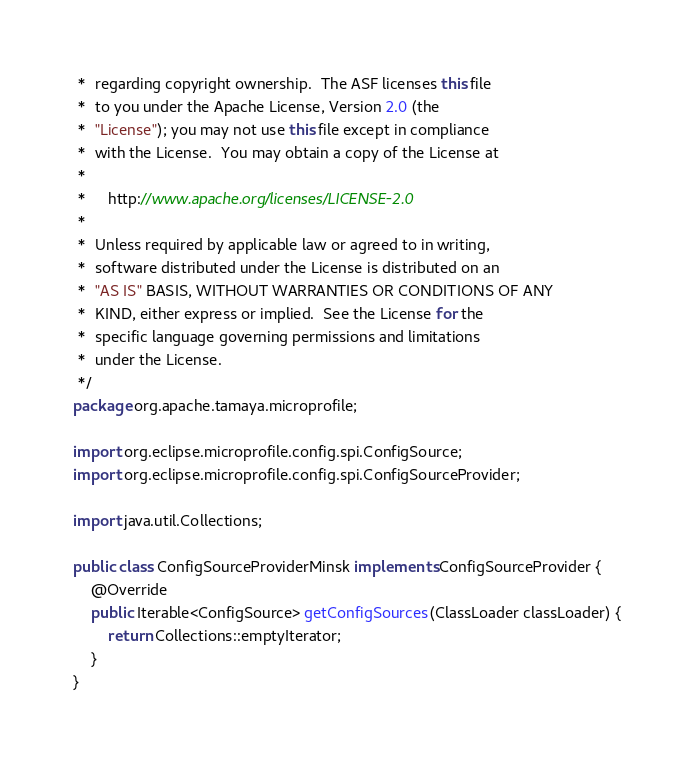<code> <loc_0><loc_0><loc_500><loc_500><_Java_> *  regarding copyright ownership.  The ASF licenses this file
 *  to you under the Apache License, Version 2.0 (the
 *  "License"); you may not use this file except in compliance
 *  with the License.  You may obtain a copy of the License at
 *
 *     http://www.apache.org/licenses/LICENSE-2.0
 *
 *  Unless required by applicable law or agreed to in writing,
 *  software distributed under the License is distributed on an
 *  "AS IS" BASIS, WITHOUT WARRANTIES OR CONDITIONS OF ANY
 *  KIND, either express or implied.  See the License for the
 *  specific language governing permissions and limitations
 *  under the License.
 */
package org.apache.tamaya.microprofile;

import org.eclipse.microprofile.config.spi.ConfigSource;
import org.eclipse.microprofile.config.spi.ConfigSourceProvider;

import java.util.Collections;

public class ConfigSourceProviderMinsk implements ConfigSourceProvider {
    @Override
    public Iterable<ConfigSource> getConfigSources(ClassLoader classLoader) {
        return Collections::emptyIterator;
    }
}
</code> 